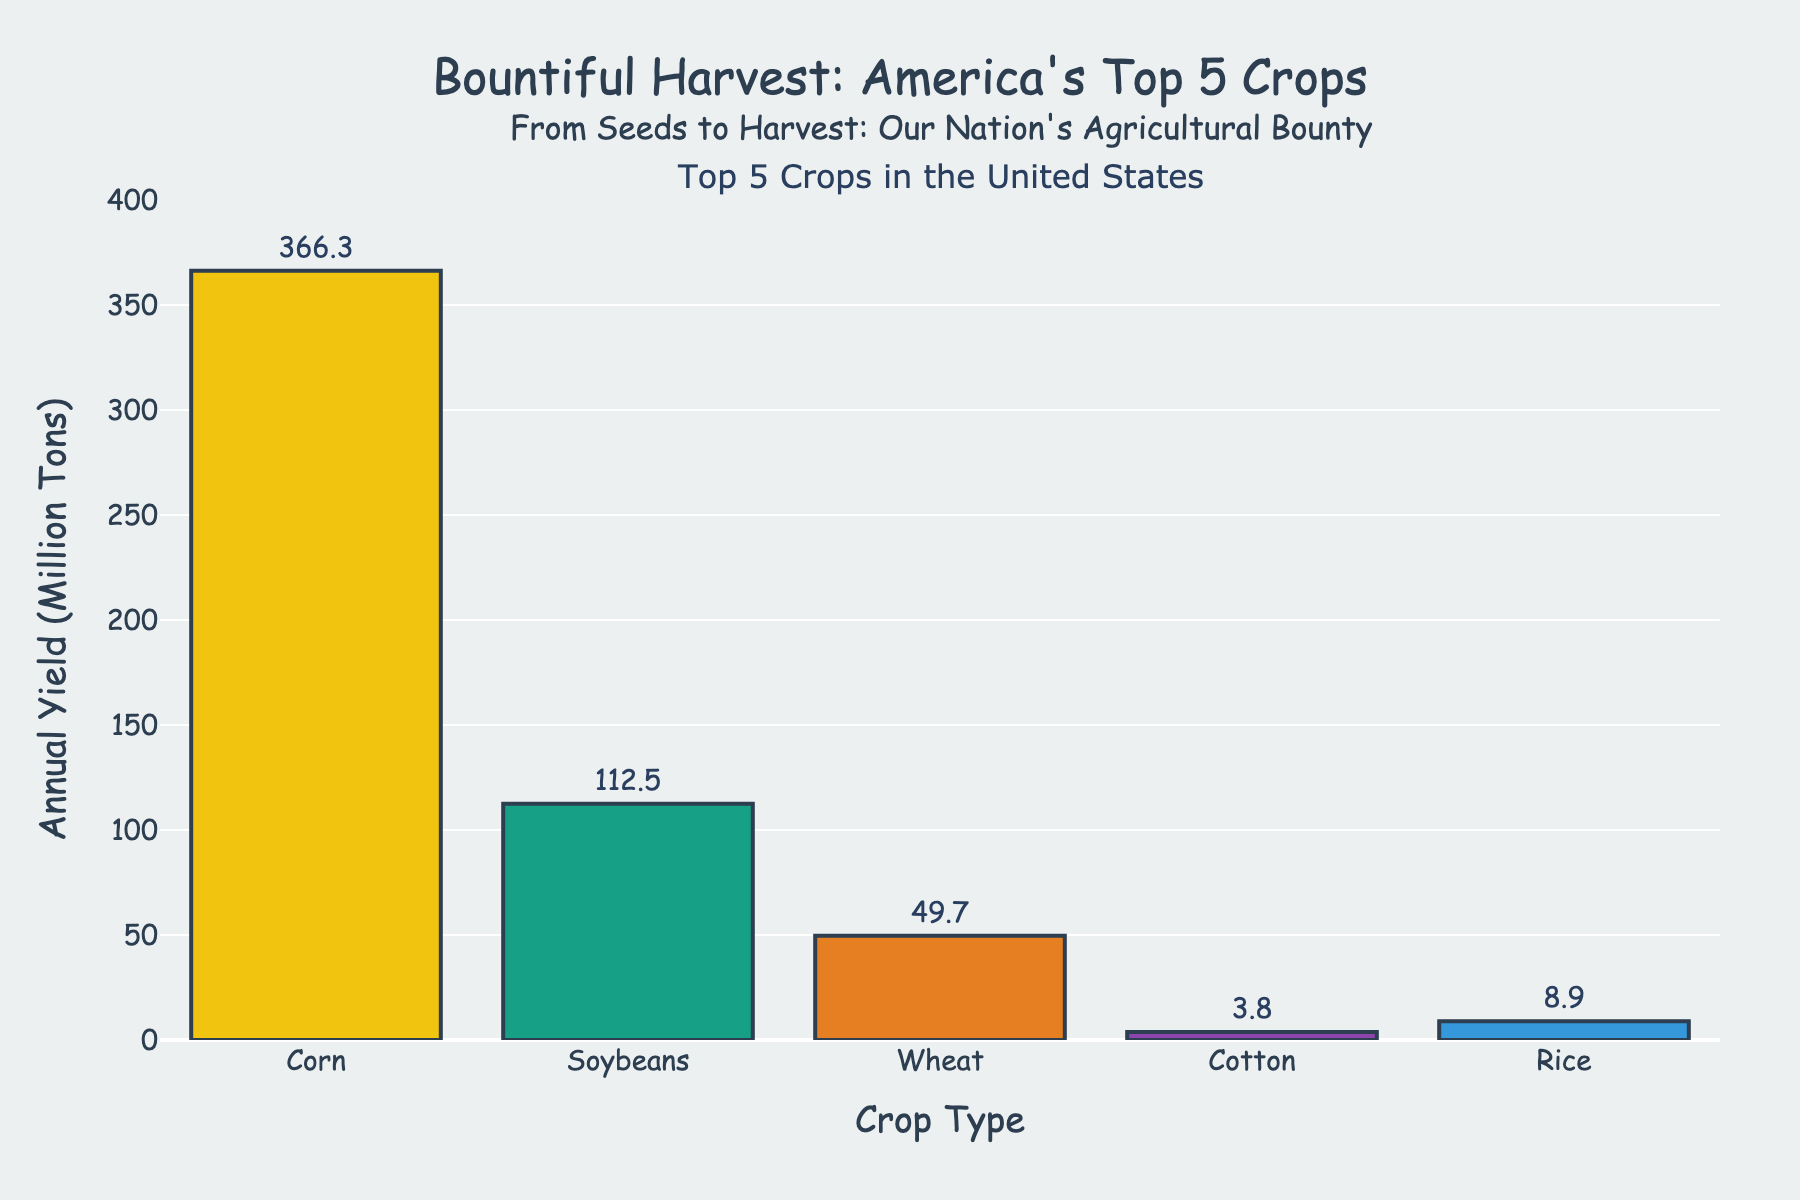What are the top 5 crops produced in the United States in terms of yield? By looking at the x-axis of the bar chart, we see the labels for the top 5 crops: Corn, Soybeans, Wheat, Cotton, and Rice.
Answer: Corn, Soybeans, Wheat, Cotton, Rice Which crop has the highest annual yield? The height of the bars indicates the annual yield, and the Corn bar is the tallest.
Answer: Corn What is the combined annual yield of Soybeans and Wheat? The annual yield for Soybeans is 112.5 million tons, and for Wheat, it is 49.7 million tons. Adding them gives 112.5 + 49.7 = 162.2 million tons.
Answer: 162.2 million tons How much greater is the yield of Corn compared to Rice? Corn has an annual yield of 366.3 million tons, while Rice has 8.9 million tons. The difference is 366.3 - 8.9 = 357.4 million tons.
Answer: 357.4 million tons If Rice and Cotton were combined into a single category, how would their combined yield compare to Wheat? Rice yields 8.9 million tons, and Cotton yields 3.8 million tons, thus their combined yield is 8.9 + 3.8 = 12.7 million tons. Wheat yields 49.7 million tons, so combined Rice and Cotton yield less than Wheat.
Answer: Combined Rice and Cotton yield less than Wheat Which crop is represented by the green bar? By examining the colors of the bars, the green bar corresponds to Soybeans.
Answer: Soybeans Rank the crops from highest to lowest yield. The bars' heights indicate yield values: Corn (366.3), Soybeans (112.5), Wheat (49.7), Rice (8.9), and Cotton (3.8). Listing them in descending order: Corn, Soybeans, Wheat, Rice, Cotton.
Answer: Corn, Soybeans, Wheat, Rice, Cotton What is the average yield of the top three crops? The yields for the top three crops are Corn (366.3), Soybeans (112.5), and Wheat (49.7). The average is (366.3 + 112.5 + 49.7)/3 = 176.1667 million tons.
Answer: 176.1667 million tons Which crop has the smallest yield, and what is its value? The shortest bar represents Cotton, which has an annual yield of 3.8 million tons.
Answer: Cotton, 3.8 million tons 